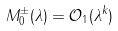<formula> <loc_0><loc_0><loc_500><loc_500>M _ { 0 } ^ { \pm } ( \lambda ) = \mathcal { O } _ { 1 } ( \lambda ^ { k } )</formula> 